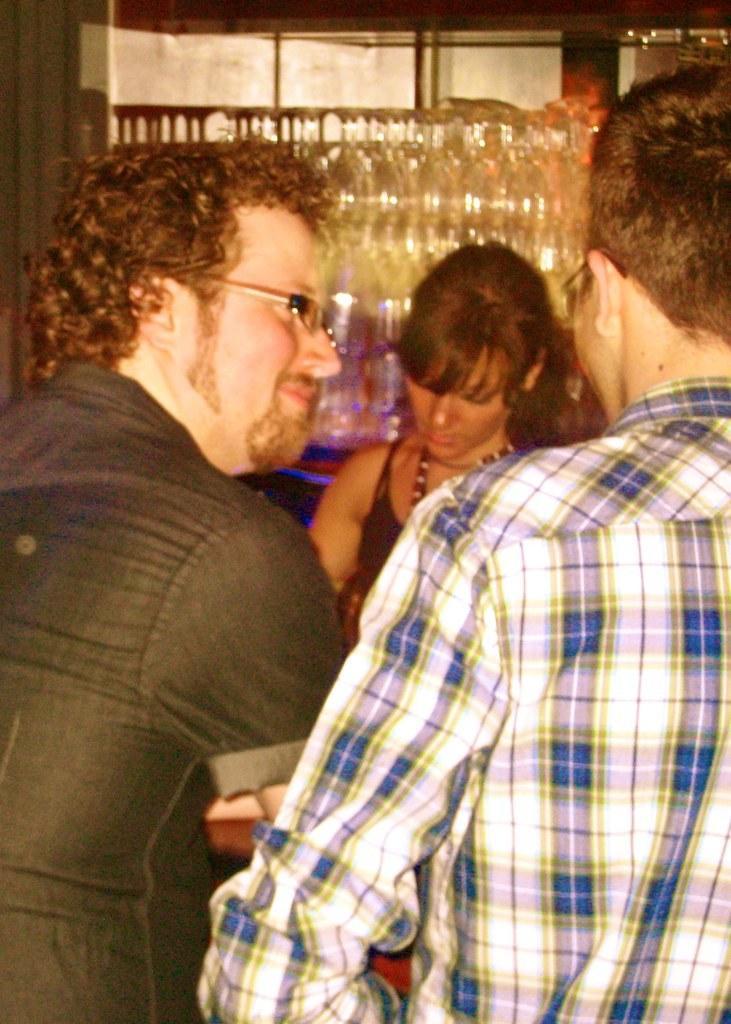How would you summarize this image in a sentence or two? In this image there are group of persons. In the front on the left side there is a man smiling. In the background there is a woman and behind the women there are glasses. 